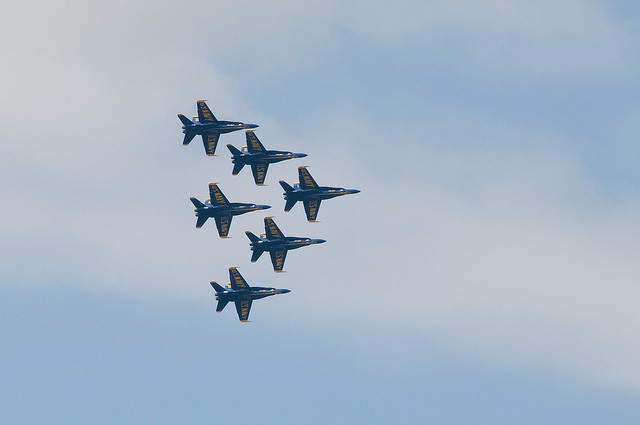<image>What number is on the middle plane? I am not sure. The number on the middle plane could be '1', '12', '4', '5', '40' or 'usa'. What number is on the middle plane? The number on the middle plane is uncertain. It can be seen as '1', '12', '4', '5', '40' or 'usa', but it is difficult to read. 